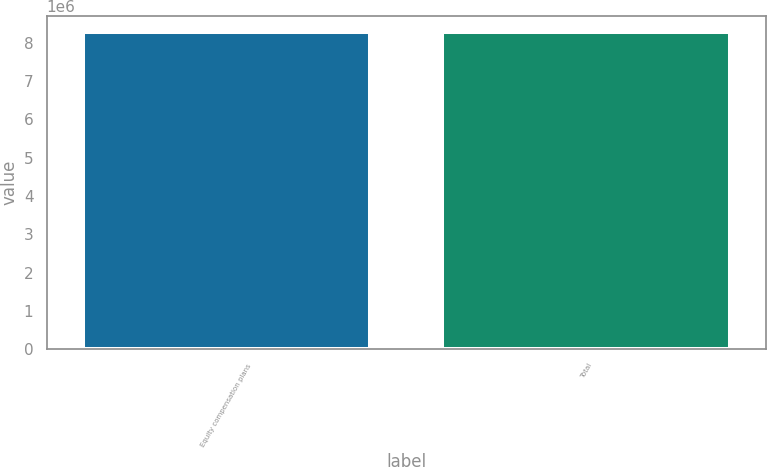Convert chart to OTSL. <chart><loc_0><loc_0><loc_500><loc_500><bar_chart><fcel>Equity compensation plans<fcel>Total<nl><fcel>8.28995e+06<fcel>8.28995e+06<nl></chart> 